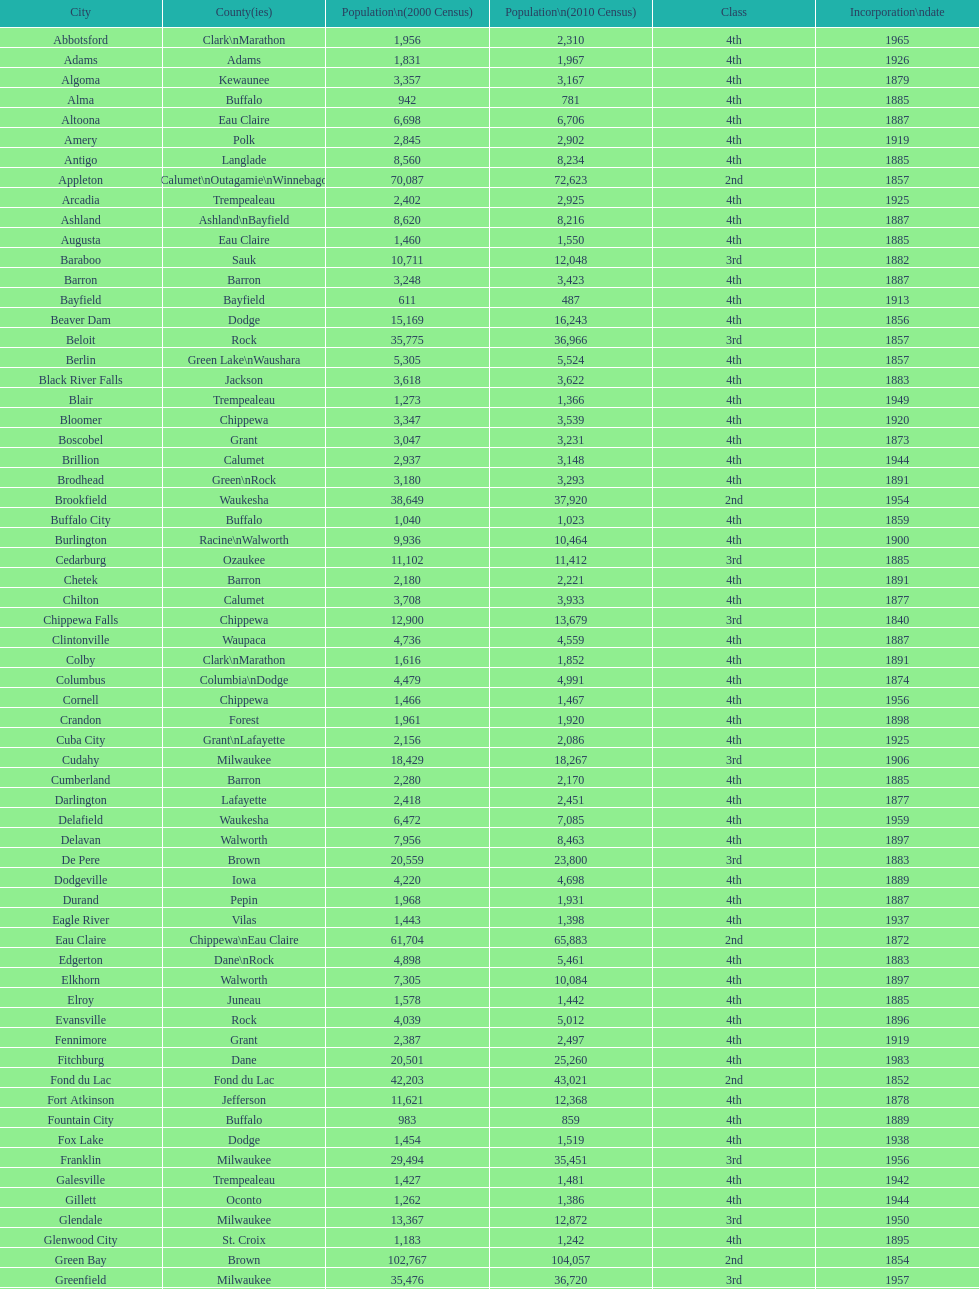County has altoona and augusta? Eau Claire. 